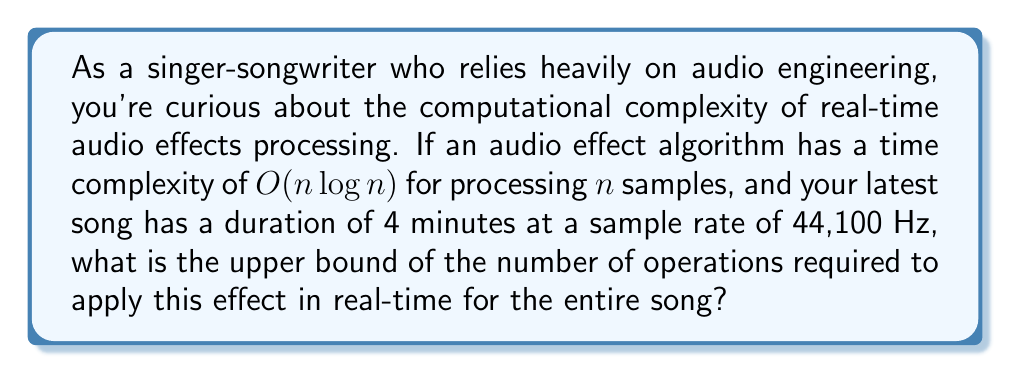Could you help me with this problem? To solve this problem, we need to follow these steps:

1. Calculate the total number of samples in the song:
   - Duration = 4 minutes = 240 seconds
   - Sample rate = 44,100 Hz (samples per second)
   - Total samples = 240 * 44,100 = 10,584,000 samples

2. Apply the time complexity formula:
   - The algorithm has a time complexity of $O(n \log n)$
   - $n = 10,584,000$

3. Calculate $n \log n$:
   $$10,584,000 \log 10,584,000$$

4. Simplify:
   $$10,584,000 * \log 10,584,000 \approx 10,584,000 * 16.47 \approx 174,318,480,000$$

The result represents the upper bound of the number of operations required to process the entire song in real-time using this audio effect algorithm.

It's important to note that this is an asymptotic upper bound, and the actual number of operations may be lower. However, this gives us an idea of the computational complexity involved in real-time audio processing.
Answer: The upper bound of the number of operations required to apply the audio effect in real-time for the entire song is approximately $1.74 \times 10^{11}$ (174,318,480,000) operations. 